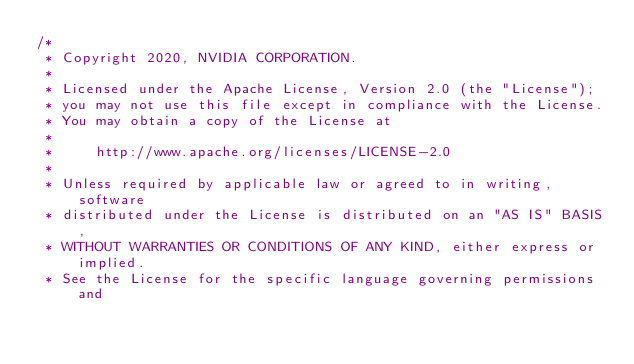<code> <loc_0><loc_0><loc_500><loc_500><_Cuda_>/*
 * Copyright 2020, NVIDIA CORPORATION.
 * 
 * Licensed under the Apache License, Version 2.0 (the "License");
 * you may not use this file except in compliance with the License.
 * You may obtain a copy of the License at
 * 
 *     http://www.apache.org/licenses/LICENSE-2.0
 * 
 * Unless required by applicable law or agreed to in writing, software
 * distributed under the License is distributed on an "AS IS" BASIS,
 * WITHOUT WARRANTIES OR CONDITIONS OF ANY KIND, either express or implied.
 * See the License for the specific language governing permissions and</code> 